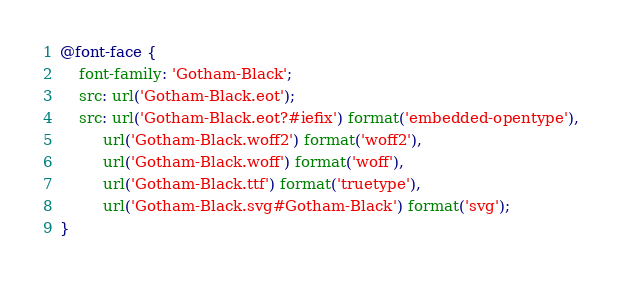Convert code to text. <code><loc_0><loc_0><loc_500><loc_500><_CSS_>@font-face {
    font-family: 'Gotham-Black';
    src: url('Gotham-Black.eot');
    src: url('Gotham-Black.eot?#iefix') format('embedded-opentype'),
         url('Gotham-Black.woff2') format('woff2'),
         url('Gotham-Black.woff') format('woff'),
         url('Gotham-Black.ttf') format('truetype'),
         url('Gotham-Black.svg#Gotham-Black') format('svg');
}



</code> 